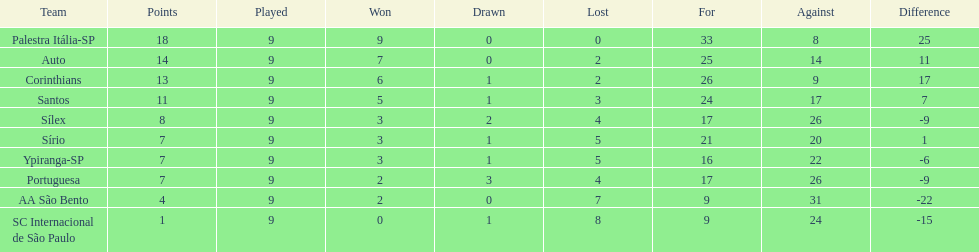In 1926 brazilian football,aside from the first place team, what other teams had winning records? Auto, Corinthians, Santos. 